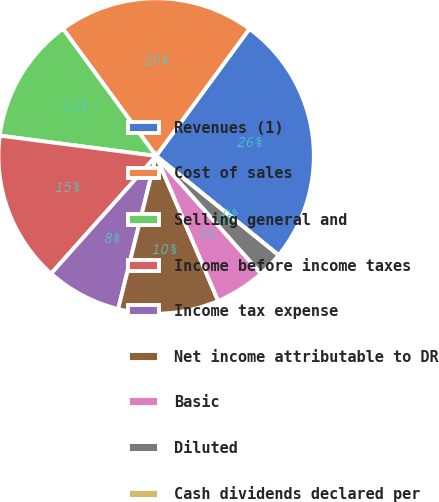<chart> <loc_0><loc_0><loc_500><loc_500><pie_chart><fcel>Revenues (1)<fcel>Cost of sales<fcel>Selling general and<fcel>Income before income taxes<fcel>Income tax expense<fcel>Net income attributable to DR<fcel>Basic<fcel>Diluted<fcel>Cash dividends declared per<nl><fcel>25.76%<fcel>20.14%<fcel>12.88%<fcel>15.46%<fcel>7.73%<fcel>10.31%<fcel>5.15%<fcel>2.58%<fcel>0.0%<nl></chart> 